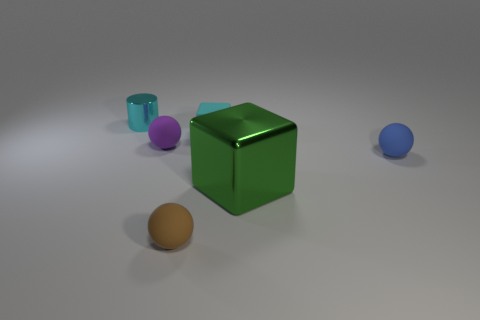Are there any other things that have the same size as the green metal cube?
Give a very brief answer. No. Is there anything else that has the same shape as the cyan shiny object?
Your response must be concise. No. What shape is the cyan shiny thing that is the same size as the rubber block?
Your answer should be very brief. Cylinder. There is a green thing that is made of the same material as the tiny cylinder; what size is it?
Offer a terse response. Large. Do the large green metal object and the purple thing have the same shape?
Keep it short and to the point. No. What color is the cylinder that is the same size as the blue matte thing?
Provide a succinct answer. Cyan. What size is the brown thing that is the same shape as the purple thing?
Your answer should be very brief. Small. There is a tiny rubber thing that is to the right of the green thing; what shape is it?
Provide a short and direct response. Sphere. Do the large green object and the small cyan thing right of the small brown object have the same shape?
Your answer should be compact. Yes. Are there the same number of tiny brown spheres that are in front of the cyan matte block and blue things that are left of the small purple ball?
Offer a very short reply. No. 